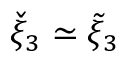<formula> <loc_0><loc_0><loc_500><loc_500>\check { \xi } _ { 3 } \simeq \tilde { \xi } _ { 3 }</formula> 